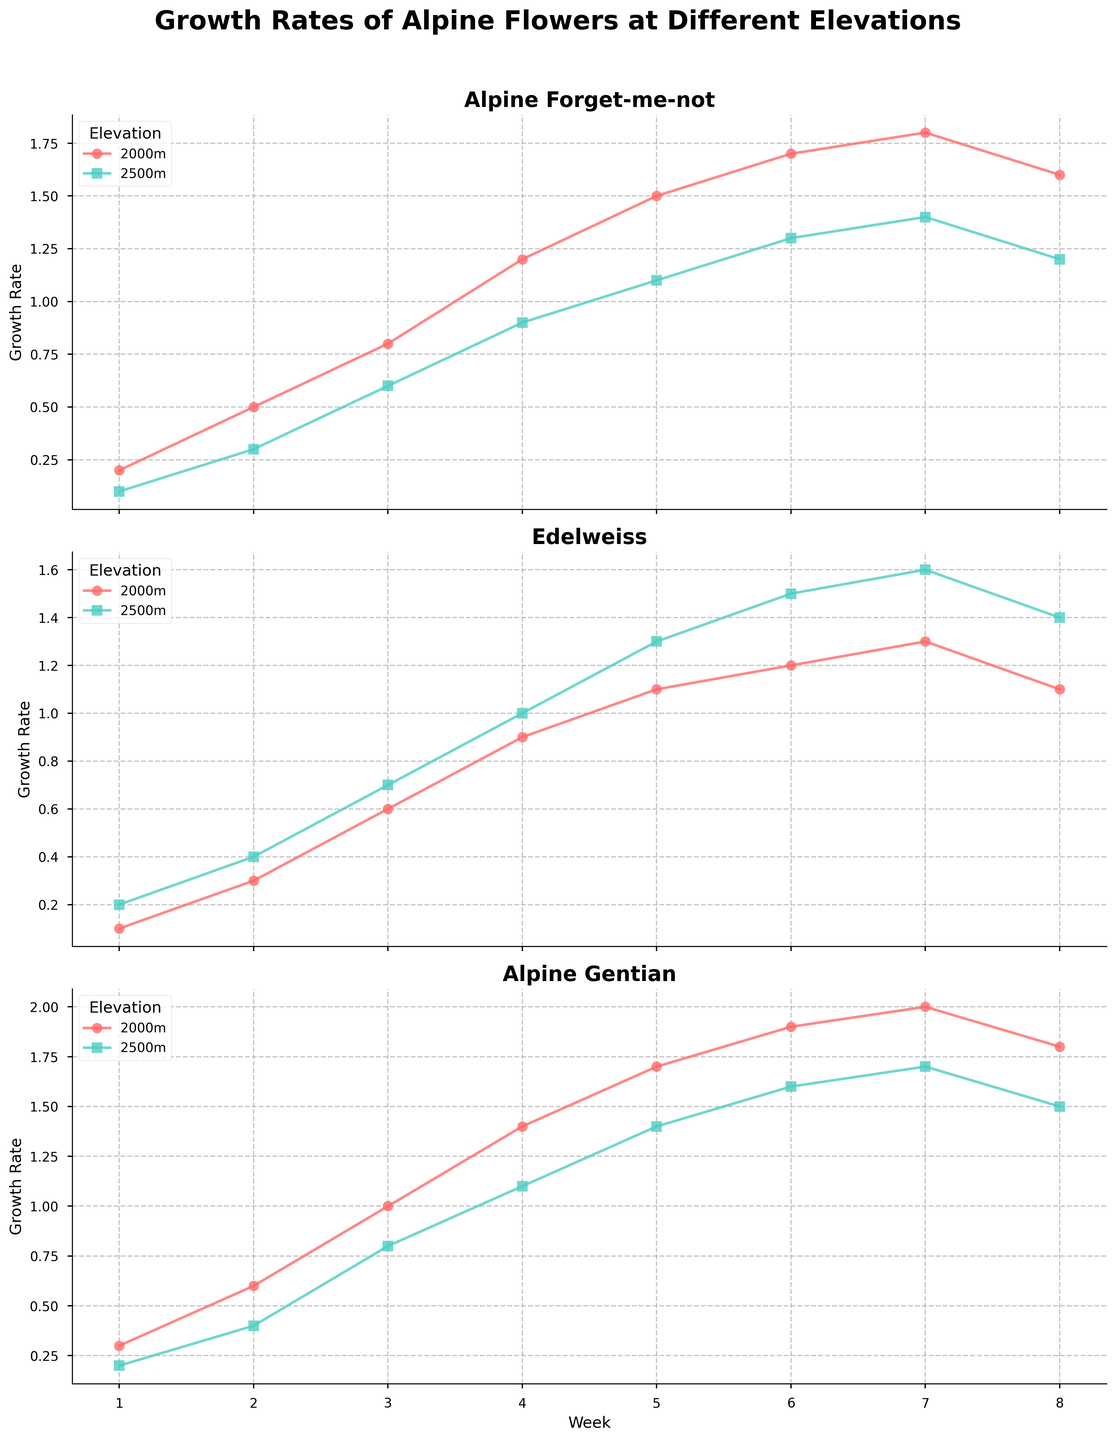Which species shows the highest growth rate at 2000m in the 8th week? Look at the 8th week data for each species at 2000m elevation and find the highest growth rate
Answer: Alpine Gentian How does the growth rate of the Alpine Forget-me-not at 2500m in the 4th week compare to the Edelweiss at the same elevation and week? Compare the growth rate values for Alpine Forget-me-not and Edelweiss at 2500m in the 4th week
Answer: Edelweiss is higher Which species has a more rapid initial growth rate at 2000m between the 1st and 2nd weeks? Compare the growth rate increase from the 1st to the 2nd week at 2000m for each species
Answer: Alpine Gentian Between 2000m and 2500m, at which elevation does Edelweiss show a greater growth rate difference from week 4 to week 5? Calculate the growth rate difference between week 4 and week 5 for Edelweiss at both elevations
Answer: 2500m Which flower species has the most consistent growth rate (least fluctuations) between weeks at 2000m elevation? Observe the growth rate curves for each species at 2000m and identify the one with the least deviations
Answer: Edelweiss At what week(s) do Alpine Forget-me-not and Alpine Gentian at 2500m both reach a growth rate of 1.2? Identify the weeks where both species at 2500m have a growth rate of 1.2 by looking at their curves
Answer: Week 8 Between weeks 1 and 8, which species shows the overall highest growth rate increase at 2000m elevation? Calculate the growth rate increase from week 1 to week 8 for each species at 2000m
Answer: Alpine Gentian How do the peak growth rates of Alpine Gentian at 2000m and 2500m compare? Compare the maximum growth rate values reached by Alpine Gentian at each elevation
Answer: 2000m is higher For Edelweiss at 2500m, by how much does the growth rate increase from the 5th to the 6th week? Find the difference in growth rates between the 5th and 6th weeks at 2500m for Edelweiss
Answer: 0.2 